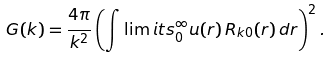<formula> <loc_0><loc_0><loc_500><loc_500>G ( k ) = \frac { 4 \pi } { k ^ { 2 } } \left ( \int \lim i t s _ { 0 } ^ { \infty } u ( r ) \, R _ { k 0 } ( r ) \, d r \right ) ^ { 2 } .</formula> 